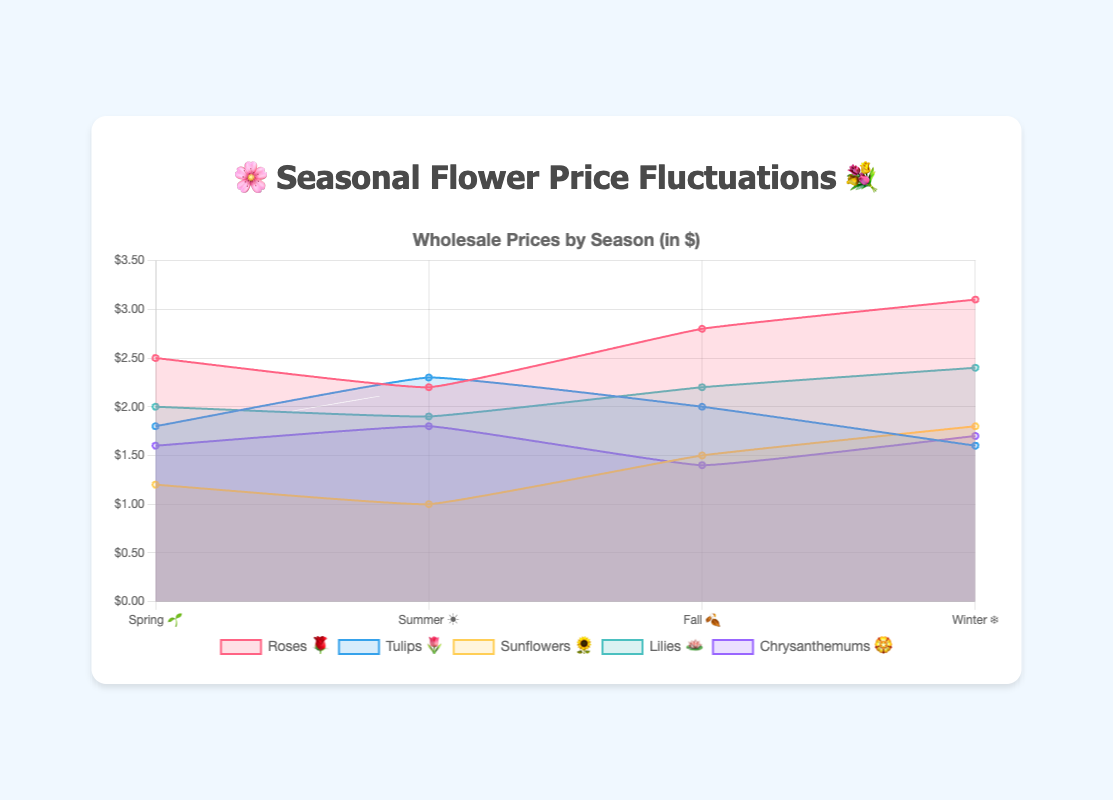Which flower has the highest price in Winter? By looking at the chart, identify the flower with the highest data point in the Winter season. "Roses 🌹" have the highest price of $3.10 in Winter.
Answer: Roses 🌹 During which season are Tulips 🌷 most expensive? Identify the highest data point for Tulips 🌷 among the four seasons. Tulips 🌷 are most expensive in Summer with a price of $2.30.
Answer: Summer ☀️ How does the price of Sunflowers 🌻 change from Spring to Summer? Compare the price points of Sunflowers 🌻 in Spring and Summer. It decreases from $1.20 in Spring to $1.00 in Summer.
Answer: Decreases Which flower has the most stable prices across the seasons? Evaluate the price fluctuation for each flower and identify the one with the least variation. Lilies 🪷 show the least fluctuation in their prices ($2.00, $1.90, $2.20, $2.40).
Answer: Lilies 🪷 What is the average price of Roses 🌹 throughout the year? Calculate the average of the prices of Roses 🌹: (2.50 + 2.20 + 2.80 + 3.10) / 4 = 2.65.
Answer: $2.65 Which flower has the lowest price in Spring? Identify the flower with the lowest data point in the Spring season. Sunflowers 🌻 have the lowest price in Spring at $1.20.
Answer: Sunflowers 🌻 What is the price difference of Chrysanthemums 🏵️ between Fall 🍂 and Winter ❄️? Subtract the price in Fall from the price in Winter for Chrysanthemums 🏵️. The difference is $1.70 - $1.40 = $0.30.
Answer: $0.30 Compare the highest prices of Roses 🌹 and Tulips 🌷. Which is higher? Identify the highest price points for each flower and compare them. Roses 🌹 have the highest price at $3.10, while Tulips 🌷 have a highest price of $2.30.
Answer: Roses 🌹 In which season do all flowers have their lowest prices? Identify the season in which the lowest price points of all flowers occur. No single season shows the lowest price for all flowers.
Answer: None What is the price range for Lilies 🪷 throughout the year? Find the difference between the highest and lowest prices of Lilies 🪷: $2.40 - $1.90 = $0.50.
Answer: $0.50 